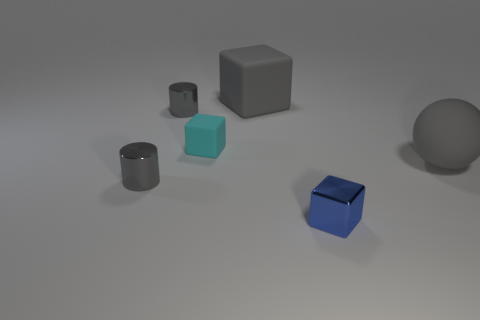What color is the small metallic thing that is both in front of the tiny cyan rubber cube and to the left of the tiny matte thing?
Your response must be concise. Gray. What number of cylinders are tiny gray metallic things or blue objects?
Provide a succinct answer. 2. Are there fewer gray objects behind the gray rubber cube than small metallic objects?
Keep it short and to the point. Yes. The big thing that is made of the same material as the gray block is what shape?
Ensure brevity in your answer.  Sphere. How many large matte blocks are the same color as the small rubber block?
Offer a very short reply. 0. How many objects are big spheres or red spheres?
Ensure brevity in your answer.  1. What material is the large gray object that is behind the small cube behind the blue block made of?
Keep it short and to the point. Rubber. Are there any small objects made of the same material as the blue block?
Offer a terse response. Yes. The big gray thing that is on the left side of the tiny thing on the right side of the tiny matte object on the left side of the sphere is what shape?
Make the answer very short. Cube. What is the cyan thing made of?
Make the answer very short. Rubber. 